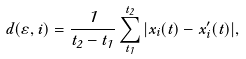<formula> <loc_0><loc_0><loc_500><loc_500>d ( \varepsilon , i ) = \frac { 1 } { t _ { 2 } - t _ { 1 } } \sum ^ { t _ { 2 } } _ { t _ { 1 } } | x _ { i } ( t ) - x ^ { \prime } _ { i } ( t ) | ,</formula> 